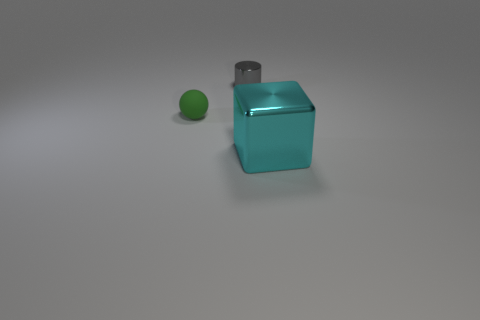Add 2 gray metallic objects. How many objects exist? 5 Subtract all cylinders. How many objects are left? 2 Subtract all red blocks. How many brown cylinders are left? 0 Subtract all purple rubber balls. Subtract all gray cylinders. How many objects are left? 2 Add 1 large metal cubes. How many large metal cubes are left? 2 Add 3 big metal objects. How many big metal objects exist? 4 Subtract 0 cyan cylinders. How many objects are left? 3 Subtract all purple cylinders. Subtract all gray balls. How many cylinders are left? 1 